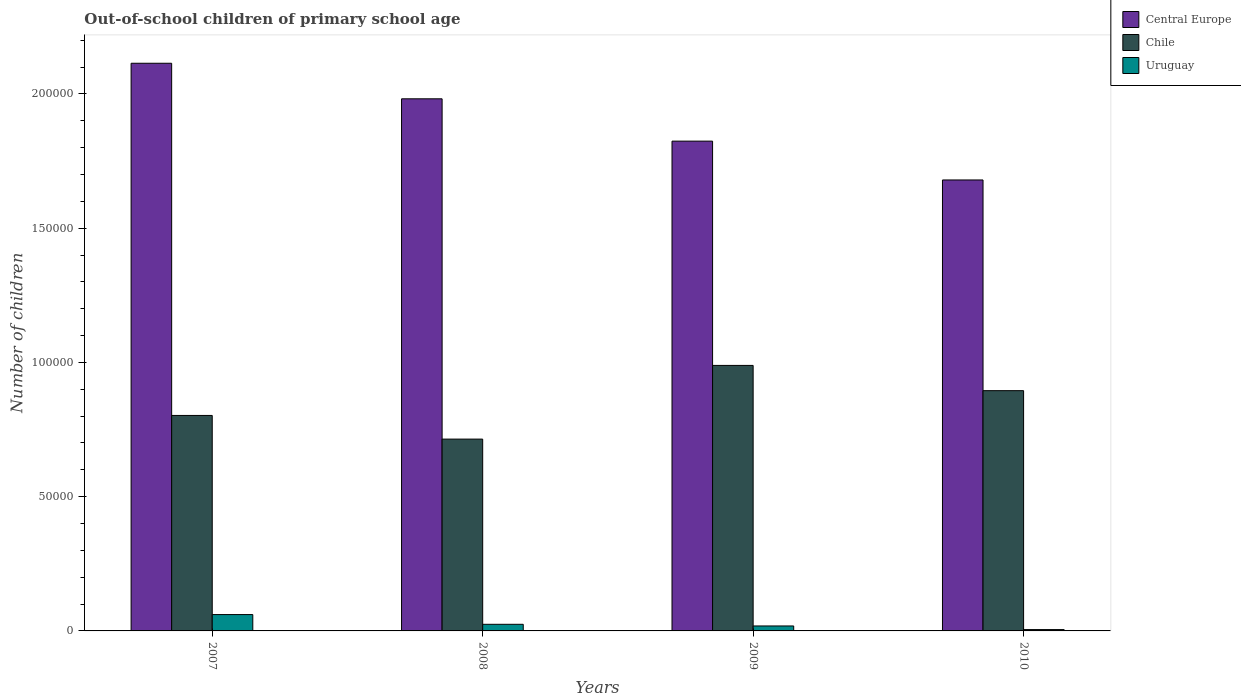How many different coloured bars are there?
Your answer should be very brief. 3. How many groups of bars are there?
Offer a terse response. 4. Are the number of bars on each tick of the X-axis equal?
Provide a succinct answer. Yes. How many bars are there on the 3rd tick from the left?
Your answer should be very brief. 3. What is the label of the 3rd group of bars from the left?
Ensure brevity in your answer.  2009. In how many cases, is the number of bars for a given year not equal to the number of legend labels?
Make the answer very short. 0. What is the number of out-of-school children in Uruguay in 2010?
Give a very brief answer. 496. Across all years, what is the maximum number of out-of-school children in Uruguay?
Offer a terse response. 6092. Across all years, what is the minimum number of out-of-school children in Chile?
Your answer should be compact. 7.14e+04. In which year was the number of out-of-school children in Central Europe maximum?
Offer a very short reply. 2007. In which year was the number of out-of-school children in Uruguay minimum?
Your response must be concise. 2010. What is the total number of out-of-school children in Central Europe in the graph?
Provide a succinct answer. 7.60e+05. What is the difference between the number of out-of-school children in Chile in 2007 and that in 2008?
Provide a succinct answer. 8806. What is the difference between the number of out-of-school children in Uruguay in 2007 and the number of out-of-school children in Central Europe in 2009?
Ensure brevity in your answer.  -1.76e+05. What is the average number of out-of-school children in Central Europe per year?
Keep it short and to the point. 1.90e+05. In the year 2007, what is the difference between the number of out-of-school children in Chile and number of out-of-school children in Central Europe?
Ensure brevity in your answer.  -1.31e+05. In how many years, is the number of out-of-school children in Chile greater than 130000?
Keep it short and to the point. 0. What is the ratio of the number of out-of-school children in Uruguay in 2009 to that in 2010?
Your answer should be compact. 3.73. Is the number of out-of-school children in Chile in 2007 less than that in 2009?
Your answer should be compact. Yes. Is the difference between the number of out-of-school children in Chile in 2007 and 2008 greater than the difference between the number of out-of-school children in Central Europe in 2007 and 2008?
Make the answer very short. No. What is the difference between the highest and the second highest number of out-of-school children in Central Europe?
Keep it short and to the point. 1.32e+04. What is the difference between the highest and the lowest number of out-of-school children in Central Europe?
Give a very brief answer. 4.35e+04. In how many years, is the number of out-of-school children in Central Europe greater than the average number of out-of-school children in Central Europe taken over all years?
Your answer should be very brief. 2. What does the 2nd bar from the left in 2010 represents?
Provide a succinct answer. Chile. What does the 1st bar from the right in 2008 represents?
Your answer should be very brief. Uruguay. How many bars are there?
Ensure brevity in your answer.  12. How many years are there in the graph?
Offer a very short reply. 4. What is the difference between two consecutive major ticks on the Y-axis?
Provide a short and direct response. 5.00e+04. Does the graph contain any zero values?
Keep it short and to the point. No. Does the graph contain grids?
Offer a terse response. No. How many legend labels are there?
Provide a succinct answer. 3. How are the legend labels stacked?
Keep it short and to the point. Vertical. What is the title of the graph?
Make the answer very short. Out-of-school children of primary school age. Does "Netherlands" appear as one of the legend labels in the graph?
Your answer should be compact. No. What is the label or title of the X-axis?
Offer a very short reply. Years. What is the label or title of the Y-axis?
Your response must be concise. Number of children. What is the Number of children of Central Europe in 2007?
Make the answer very short. 2.11e+05. What is the Number of children of Chile in 2007?
Your answer should be very brief. 8.02e+04. What is the Number of children of Uruguay in 2007?
Ensure brevity in your answer.  6092. What is the Number of children of Central Europe in 2008?
Your answer should be compact. 1.98e+05. What is the Number of children in Chile in 2008?
Provide a succinct answer. 7.14e+04. What is the Number of children of Uruguay in 2008?
Provide a short and direct response. 2462. What is the Number of children in Central Europe in 2009?
Give a very brief answer. 1.82e+05. What is the Number of children in Chile in 2009?
Offer a very short reply. 9.89e+04. What is the Number of children of Uruguay in 2009?
Your response must be concise. 1848. What is the Number of children of Central Europe in 2010?
Your answer should be very brief. 1.68e+05. What is the Number of children in Chile in 2010?
Your answer should be very brief. 8.95e+04. What is the Number of children of Uruguay in 2010?
Ensure brevity in your answer.  496. Across all years, what is the maximum Number of children in Central Europe?
Your answer should be very brief. 2.11e+05. Across all years, what is the maximum Number of children of Chile?
Keep it short and to the point. 9.89e+04. Across all years, what is the maximum Number of children in Uruguay?
Offer a terse response. 6092. Across all years, what is the minimum Number of children in Central Europe?
Make the answer very short. 1.68e+05. Across all years, what is the minimum Number of children of Chile?
Provide a short and direct response. 7.14e+04. Across all years, what is the minimum Number of children in Uruguay?
Keep it short and to the point. 496. What is the total Number of children in Central Europe in the graph?
Offer a terse response. 7.60e+05. What is the total Number of children in Chile in the graph?
Offer a very short reply. 3.40e+05. What is the total Number of children in Uruguay in the graph?
Keep it short and to the point. 1.09e+04. What is the difference between the Number of children of Central Europe in 2007 and that in 2008?
Your answer should be very brief. 1.32e+04. What is the difference between the Number of children in Chile in 2007 and that in 2008?
Ensure brevity in your answer.  8806. What is the difference between the Number of children in Uruguay in 2007 and that in 2008?
Your answer should be compact. 3630. What is the difference between the Number of children of Central Europe in 2007 and that in 2009?
Provide a short and direct response. 2.90e+04. What is the difference between the Number of children in Chile in 2007 and that in 2009?
Your answer should be very brief. -1.86e+04. What is the difference between the Number of children in Uruguay in 2007 and that in 2009?
Give a very brief answer. 4244. What is the difference between the Number of children of Central Europe in 2007 and that in 2010?
Provide a short and direct response. 4.35e+04. What is the difference between the Number of children of Chile in 2007 and that in 2010?
Make the answer very short. -9233. What is the difference between the Number of children of Uruguay in 2007 and that in 2010?
Give a very brief answer. 5596. What is the difference between the Number of children of Central Europe in 2008 and that in 2009?
Offer a very short reply. 1.58e+04. What is the difference between the Number of children in Chile in 2008 and that in 2009?
Your answer should be compact. -2.74e+04. What is the difference between the Number of children of Uruguay in 2008 and that in 2009?
Your response must be concise. 614. What is the difference between the Number of children in Central Europe in 2008 and that in 2010?
Your answer should be very brief. 3.02e+04. What is the difference between the Number of children in Chile in 2008 and that in 2010?
Provide a short and direct response. -1.80e+04. What is the difference between the Number of children in Uruguay in 2008 and that in 2010?
Your answer should be compact. 1966. What is the difference between the Number of children in Central Europe in 2009 and that in 2010?
Your answer should be very brief. 1.45e+04. What is the difference between the Number of children of Chile in 2009 and that in 2010?
Make the answer very short. 9402. What is the difference between the Number of children in Uruguay in 2009 and that in 2010?
Ensure brevity in your answer.  1352. What is the difference between the Number of children of Central Europe in 2007 and the Number of children of Chile in 2008?
Make the answer very short. 1.40e+05. What is the difference between the Number of children of Central Europe in 2007 and the Number of children of Uruguay in 2008?
Make the answer very short. 2.09e+05. What is the difference between the Number of children of Chile in 2007 and the Number of children of Uruguay in 2008?
Offer a very short reply. 7.78e+04. What is the difference between the Number of children of Central Europe in 2007 and the Number of children of Chile in 2009?
Make the answer very short. 1.13e+05. What is the difference between the Number of children in Central Europe in 2007 and the Number of children in Uruguay in 2009?
Keep it short and to the point. 2.10e+05. What is the difference between the Number of children of Chile in 2007 and the Number of children of Uruguay in 2009?
Your answer should be compact. 7.84e+04. What is the difference between the Number of children in Central Europe in 2007 and the Number of children in Chile in 2010?
Offer a very short reply. 1.22e+05. What is the difference between the Number of children of Central Europe in 2007 and the Number of children of Uruguay in 2010?
Your response must be concise. 2.11e+05. What is the difference between the Number of children in Chile in 2007 and the Number of children in Uruguay in 2010?
Provide a succinct answer. 7.98e+04. What is the difference between the Number of children in Central Europe in 2008 and the Number of children in Chile in 2009?
Your answer should be compact. 9.93e+04. What is the difference between the Number of children of Central Europe in 2008 and the Number of children of Uruguay in 2009?
Make the answer very short. 1.96e+05. What is the difference between the Number of children in Chile in 2008 and the Number of children in Uruguay in 2009?
Ensure brevity in your answer.  6.96e+04. What is the difference between the Number of children of Central Europe in 2008 and the Number of children of Chile in 2010?
Provide a short and direct response. 1.09e+05. What is the difference between the Number of children of Central Europe in 2008 and the Number of children of Uruguay in 2010?
Provide a short and direct response. 1.98e+05. What is the difference between the Number of children in Chile in 2008 and the Number of children in Uruguay in 2010?
Your answer should be very brief. 7.09e+04. What is the difference between the Number of children of Central Europe in 2009 and the Number of children of Chile in 2010?
Your response must be concise. 9.29e+04. What is the difference between the Number of children of Central Europe in 2009 and the Number of children of Uruguay in 2010?
Provide a short and direct response. 1.82e+05. What is the difference between the Number of children in Chile in 2009 and the Number of children in Uruguay in 2010?
Keep it short and to the point. 9.84e+04. What is the average Number of children in Central Europe per year?
Keep it short and to the point. 1.90e+05. What is the average Number of children in Chile per year?
Offer a very short reply. 8.50e+04. What is the average Number of children of Uruguay per year?
Provide a succinct answer. 2724.5. In the year 2007, what is the difference between the Number of children of Central Europe and Number of children of Chile?
Give a very brief answer. 1.31e+05. In the year 2007, what is the difference between the Number of children in Central Europe and Number of children in Uruguay?
Provide a short and direct response. 2.05e+05. In the year 2007, what is the difference between the Number of children in Chile and Number of children in Uruguay?
Keep it short and to the point. 7.42e+04. In the year 2008, what is the difference between the Number of children of Central Europe and Number of children of Chile?
Offer a terse response. 1.27e+05. In the year 2008, what is the difference between the Number of children of Central Europe and Number of children of Uruguay?
Your answer should be compact. 1.96e+05. In the year 2008, what is the difference between the Number of children of Chile and Number of children of Uruguay?
Ensure brevity in your answer.  6.90e+04. In the year 2009, what is the difference between the Number of children of Central Europe and Number of children of Chile?
Provide a short and direct response. 8.35e+04. In the year 2009, what is the difference between the Number of children in Central Europe and Number of children in Uruguay?
Provide a short and direct response. 1.81e+05. In the year 2009, what is the difference between the Number of children of Chile and Number of children of Uruguay?
Your response must be concise. 9.70e+04. In the year 2010, what is the difference between the Number of children in Central Europe and Number of children in Chile?
Keep it short and to the point. 7.85e+04. In the year 2010, what is the difference between the Number of children in Central Europe and Number of children in Uruguay?
Provide a short and direct response. 1.67e+05. In the year 2010, what is the difference between the Number of children of Chile and Number of children of Uruguay?
Ensure brevity in your answer.  8.90e+04. What is the ratio of the Number of children of Central Europe in 2007 to that in 2008?
Offer a very short reply. 1.07. What is the ratio of the Number of children in Chile in 2007 to that in 2008?
Provide a short and direct response. 1.12. What is the ratio of the Number of children in Uruguay in 2007 to that in 2008?
Your response must be concise. 2.47. What is the ratio of the Number of children of Central Europe in 2007 to that in 2009?
Your answer should be compact. 1.16. What is the ratio of the Number of children in Chile in 2007 to that in 2009?
Offer a very short reply. 0.81. What is the ratio of the Number of children of Uruguay in 2007 to that in 2009?
Make the answer very short. 3.3. What is the ratio of the Number of children of Central Europe in 2007 to that in 2010?
Your response must be concise. 1.26. What is the ratio of the Number of children of Chile in 2007 to that in 2010?
Provide a succinct answer. 0.9. What is the ratio of the Number of children in Uruguay in 2007 to that in 2010?
Make the answer very short. 12.28. What is the ratio of the Number of children in Central Europe in 2008 to that in 2009?
Make the answer very short. 1.09. What is the ratio of the Number of children in Chile in 2008 to that in 2009?
Make the answer very short. 0.72. What is the ratio of the Number of children in Uruguay in 2008 to that in 2009?
Provide a short and direct response. 1.33. What is the ratio of the Number of children in Central Europe in 2008 to that in 2010?
Your answer should be very brief. 1.18. What is the ratio of the Number of children in Chile in 2008 to that in 2010?
Make the answer very short. 0.8. What is the ratio of the Number of children of Uruguay in 2008 to that in 2010?
Your answer should be compact. 4.96. What is the ratio of the Number of children in Central Europe in 2009 to that in 2010?
Your answer should be very brief. 1.09. What is the ratio of the Number of children of Chile in 2009 to that in 2010?
Offer a very short reply. 1.11. What is the ratio of the Number of children of Uruguay in 2009 to that in 2010?
Your response must be concise. 3.73. What is the difference between the highest and the second highest Number of children of Central Europe?
Make the answer very short. 1.32e+04. What is the difference between the highest and the second highest Number of children in Chile?
Your response must be concise. 9402. What is the difference between the highest and the second highest Number of children of Uruguay?
Ensure brevity in your answer.  3630. What is the difference between the highest and the lowest Number of children of Central Europe?
Make the answer very short. 4.35e+04. What is the difference between the highest and the lowest Number of children in Chile?
Your response must be concise. 2.74e+04. What is the difference between the highest and the lowest Number of children in Uruguay?
Provide a short and direct response. 5596. 